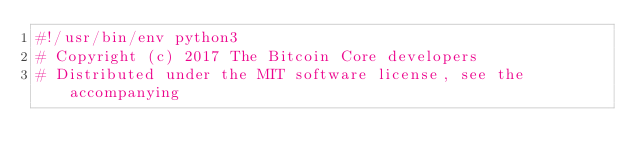<code> <loc_0><loc_0><loc_500><loc_500><_Python_>#!/usr/bin/env python3
# Copyright (c) 2017 The Bitcoin Core developers
# Distributed under the MIT software license, see the accompanying</code> 